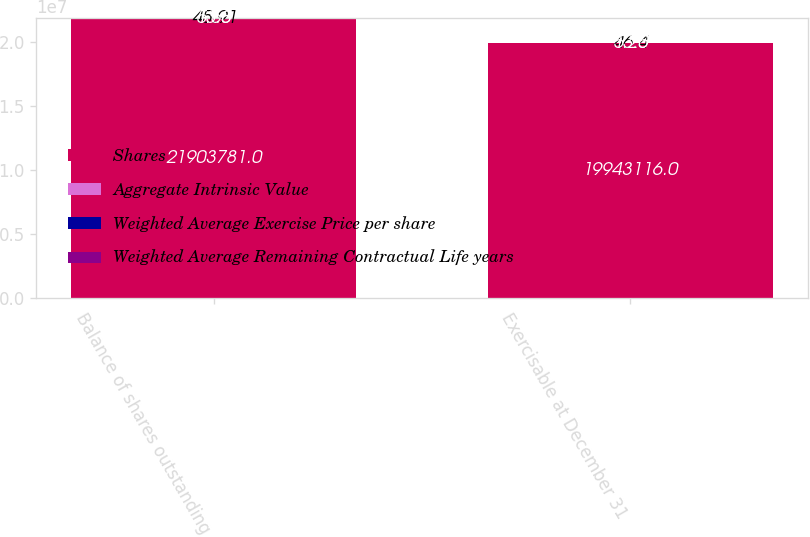<chart> <loc_0><loc_0><loc_500><loc_500><stacked_bar_chart><ecel><fcel>Balance of shares outstanding<fcel>Exercisable at December 31<nl><fcel>Shares<fcel>2.19038e+07<fcel>1.99431e+07<nl><fcel>Aggregate Intrinsic Value<fcel>45.91<fcel>46.4<nl><fcel>Weighted Average Exercise Price per share<fcel>5.58<fcel>5.25<nl><fcel>Weighted Average Remaining Contractual Life years<fcel>13<fcel>13<nl></chart> 